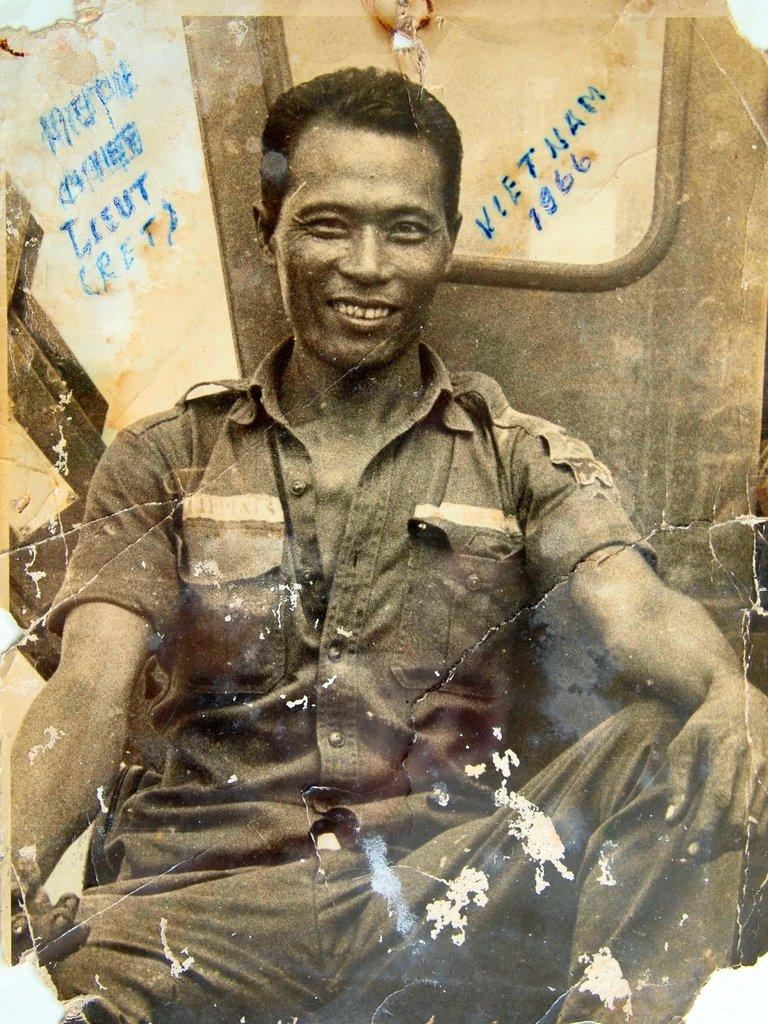What type of image is shown in the photograph? The image appears to be a photograph. What is the person in the photograph doing? The person is sitting in the photograph. What expression does the person have? The person is smiling. What can be seen in the background of the photograph? There is a door and a wall with text visible in the background. How many squirrels are climbing on the person's shoulder in the photograph? There are no squirrels present in the photograph. What team is the person representing in the photograph? There is no indication of a team or any affiliation in the photograph. 